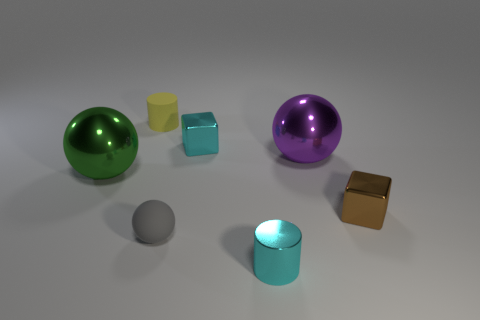Add 1 large brown cylinders. How many objects exist? 8 Subtract all brown cubes. How many cubes are left? 1 Subtract all small rubber balls. How many balls are left? 2 Subtract all blocks. How many objects are left? 5 Subtract all purple blocks. Subtract all blue balls. How many blocks are left? 2 Subtract all large green metal balls. Subtract all brown shiny blocks. How many objects are left? 5 Add 3 shiny cylinders. How many shiny cylinders are left? 4 Add 4 small green metallic balls. How many small green metallic balls exist? 4 Subtract 1 cyan blocks. How many objects are left? 6 Subtract 2 blocks. How many blocks are left? 0 